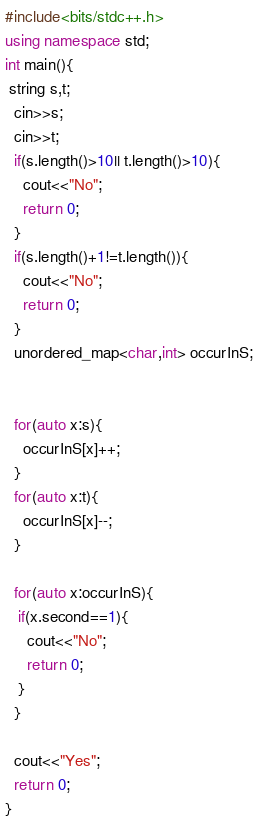Convert code to text. <code><loc_0><loc_0><loc_500><loc_500><_C++_>#include<bits/stdc++.h>
using namespace std;
int main(){
 string s,t;
  cin>>s;
  cin>>t;
  if(s.length()>10|| t.length()>10){
  	cout<<"No";
    return 0;
  }
  if(s.length()+1!=t.length()){
    cout<<"No";
    return 0;
  }
  unordered_map<char,int> occurInS;
  
	
  for(auto x:s){
    occurInS[x]++;
  }
  for(auto x:t){
    occurInS[x]--;
  }
  
  for(auto x:occurInS){
   if(x.second==1){
     cout<<"No";
     return 0;
   }
  }
  
  cout<<"Yes";
  return 0;
}</code> 